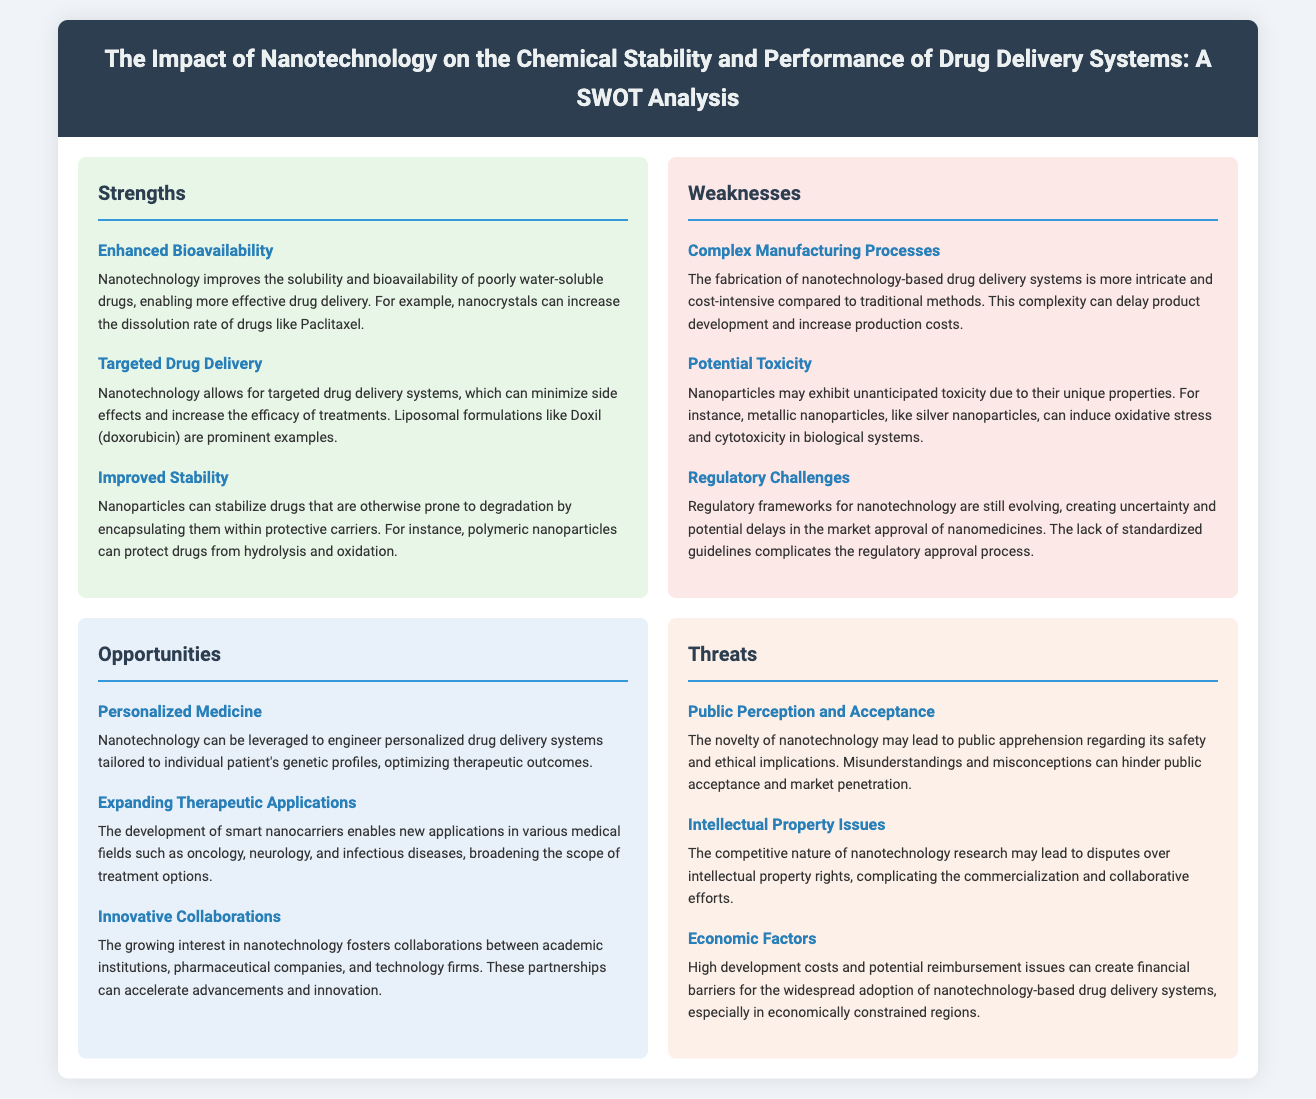what is the title of the document? The title is "The Impact of Nanotechnology on the Chemical Stability and Performance of Drug Delivery Systems: A SWOT Analysis."
Answer: The Impact of Nanotechnology on the Chemical Stability and Performance of Drug Delivery Systems: A SWOT Analysis what are the strengths listed in the document? The strengths include Enhanced Bioavailability, Targeted Drug Delivery, and Improved Stability.
Answer: Enhanced Bioavailability, Targeted Drug Delivery, Improved Stability what is one opportunity mentioned in the document? One opportunity mentioned is personalized medicine.
Answer: Personalized Medicine how many weaknesses are identified in the SWOT analysis? The document identifies three weaknesses.
Answer: Three which drug delivery system is an example of targeted drug delivery? Doxil (doxorubicin) is provided as an example of targeted drug delivery.
Answer: Doxil (doxorubicin) what potential toxicity issue is highlighted in the weaknesses? The document highlights that metallic nanoparticles can induce oxidative stress and cytotoxicity.
Answer: Oxidative stress and cytotoxicity what major threat is associated with public perception? The major threat associated with public perception is apprehension regarding safety and ethical implications.
Answer: Apprehension regarding safety and ethical implications what can stimulate innovative collaborations according to the opportunities section? The growing interest in nanotechnology can stimulate innovative collaborations.
Answer: Growing interest in nanotechnology 